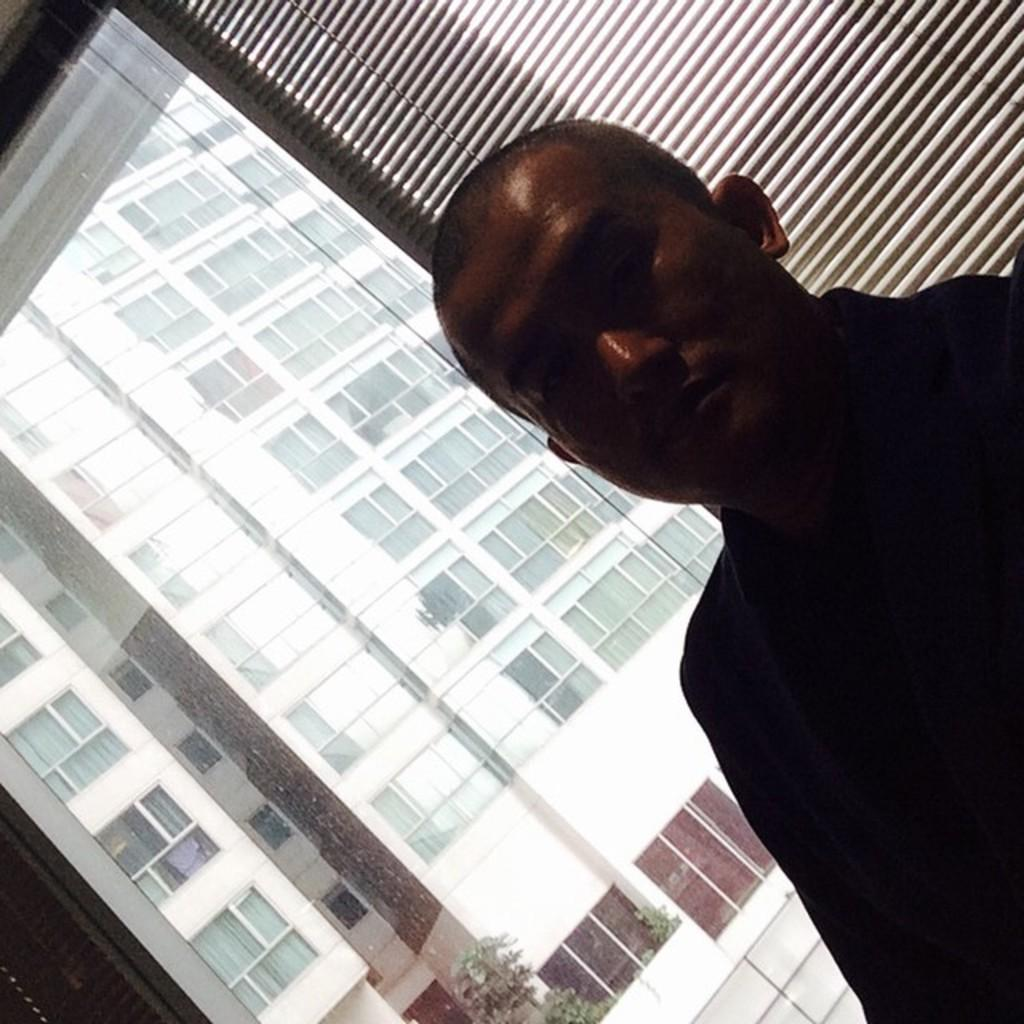What is the main subject of the image? There is a person standing in the image. What can be seen in the background of the image? There is a building behind the person in the image. What type of riddle can be solved by the person in the image? There is no riddle present in the image, nor is there any indication that the person is attempting to solve one. 